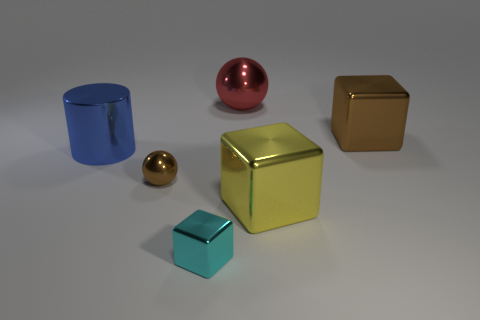There is a large thing that is the same color as the tiny sphere; what is its material?
Ensure brevity in your answer.  Metal. Are there more large red metal balls than large purple cubes?
Provide a succinct answer. Yes. Is the size of the brown block the same as the red metallic object?
Your response must be concise. Yes. What number of objects are tiny yellow matte things or brown metal cubes?
Your answer should be compact. 1. What shape is the shiny thing behind the brown shiny thing behind the brown metal thing to the left of the tiny cyan thing?
Give a very brief answer. Sphere. Are the ball behind the tiny brown thing and the small brown ball that is behind the small metallic cube made of the same material?
Your answer should be compact. Yes. There is a cyan thing that is the same shape as the big yellow thing; what is its material?
Your answer should be compact. Metal. Is there any other thing that has the same size as the brown block?
Provide a short and direct response. Yes. Is the shape of the brown thing on the right side of the tiny cube the same as the brown object that is left of the red thing?
Offer a terse response. No. Is the number of big cubes in front of the cyan cube less than the number of yellow blocks that are behind the red metal thing?
Give a very brief answer. No. 